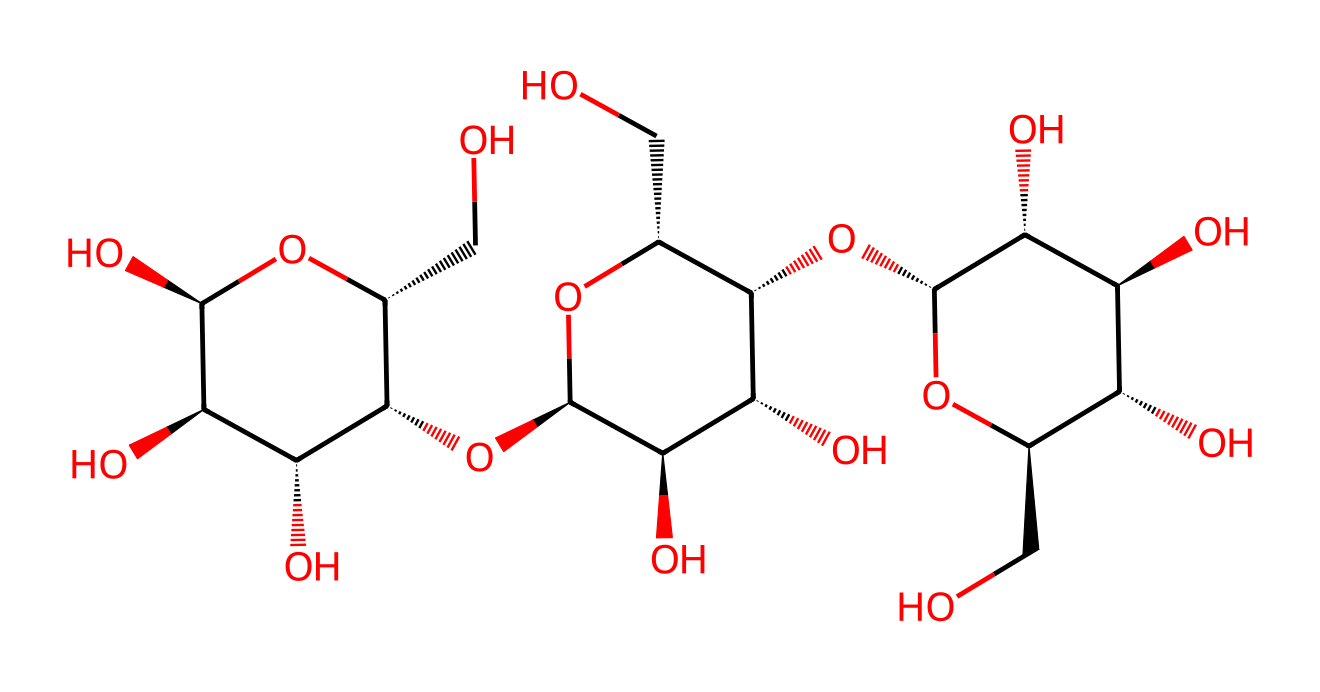What type of polymer is represented by this structure? The provided SMILES represents cellulose, which is a polysaccharide polymer made up of glucose monomers linked by beta-glycosidic bonds. This indicates that it is a polymer and specifically cellulose, commonly found in plant materials.
Answer: cellulose How many hydroxyl groups are present in the chemical structure? By analyzing the structure, we can count the hydroxyl (–OH) groups that are attached to the glucose units. The structure contains six hydroxyl groups, as seen in various parts of the glucose units in the chain.
Answer: six What is the primary source of cellulose for biodegradable fibers? Cellulose fibers are primarily obtained from natural sources such as cotton or wood. These materials are rich in cellulose, providing a sustainable resource for eco-friendly clothing.
Answer: cotton or wood Does this structure indicate that it is soluble in water? Cellulose, due to the presence of multiple hydroxyl (–OH) groups, has strong hydrogen bonding with water molecules, which affects its solubility. However, cellulose itself is not soluble in water, but it can swell.
Answer: no What is the significance of the chirality present in this chemical structure? The chirality reflects the optical activity of the glucose units, making cellulose exhibit specific spatial orientation in its structure. This affects physical properties like tensile strength and elasticity, which are significant for fibers.
Answer: affects properties How many glucose units can be identified in this cellulose structure? By analyzing the structure, we can see that there are multiple cyclic structures indicative of glucose units. Counting these will reveal that there are several glucose units present in the cellulose chain. There are actually three distinct glucose units visible in the segment provided.
Answer: three 